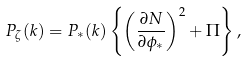Convert formula to latex. <formula><loc_0><loc_0><loc_500><loc_500>P _ { \zeta } ( k ) = P _ { \ast } ( k ) \left \{ \left ( \frac { \partial N } { \partial \phi _ { \ast } } \right ) ^ { 2 } + \Pi \right \} ,</formula> 